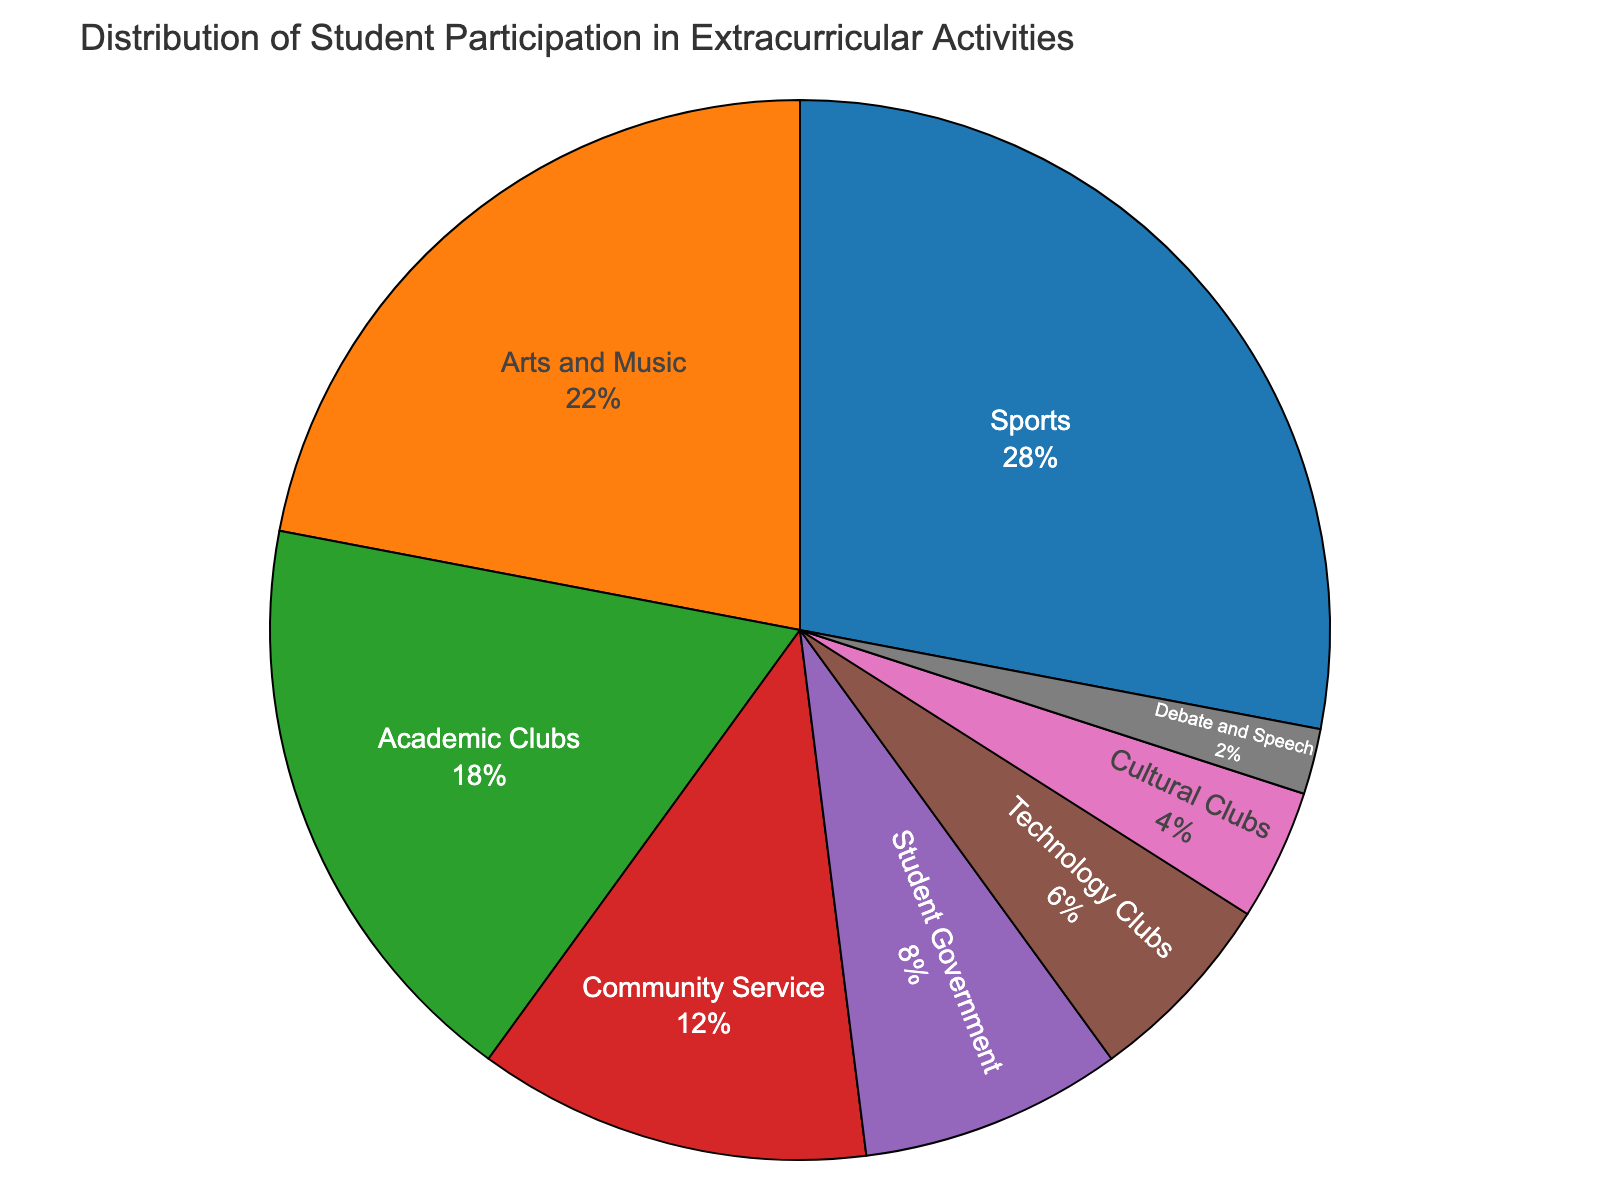Which category has the highest participation percentage? Identify the segment that represents the largest portion of the pie chart. This is color-coded and labeled accordingly.
Answer: Sports What is the combined participation percentage for Community Service and Student Government? Find the percentages for Community Service and Student Government from the pie chart and add them together: 12% + 8%.
Answer: 20% Does Arts and Music have a higher percentage than Academic Clubs? Compare the percentage values shown on the pie chart for Arts and Music (22%) and Academic Clubs (18%).
Answer: Yes Which category has the smallest participation percentage? Identify the segment with the smallest part of the pie chart. This is labeled and will be the smallest segment visually.
Answer: Debate and Speech How much more participation does Sports have compared to Technology Clubs? Subtract the percentage of Technology Clubs from the percentage of Sports: 28% - 6%.
Answer: 22% Which has greater participation: Student Government or Cultural Clubs? Compare the percentage values for Student Government (8%) and Cultural Clubs (4%).
Answer: Student Government What is the total percentage of participation in extracurricular activities? Since the pie chart shows the distribution, the total will always sum up to 100%.
Answer: 100% How do Academic Clubs and Technology Clubs participation compare visually in size? Assess the sizes of the segments for Academic Clubs and Technology Clubs visually. Academic Clubs have a larger segment in the pie chart.
Answer: Academic Clubs are larger What is the difference in participation percentages between Arts and Music and Community Service? Subtract the percentage of Community Service from Arts and Music: 22% - 12%.
Answer: 10% Which category falls between Technology Clubs and Debate and Speech in participation percentage? Visually scan the segments and labels between Technology Clubs (6%) and Debate and Speech (2%), finding Cultural Clubs (4%).
Answer: Cultural Clubs 